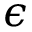Convert formula to latex. <formula><loc_0><loc_0><loc_500><loc_500>\epsilon</formula> 